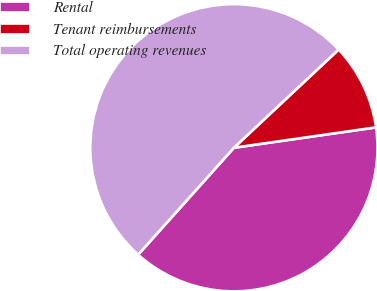Convert chart to OTSL. <chart><loc_0><loc_0><loc_500><loc_500><pie_chart><fcel>Rental<fcel>Tenant reimbursements<fcel>Total operating revenues<nl><fcel>38.89%<fcel>9.72%<fcel>51.39%<nl></chart> 